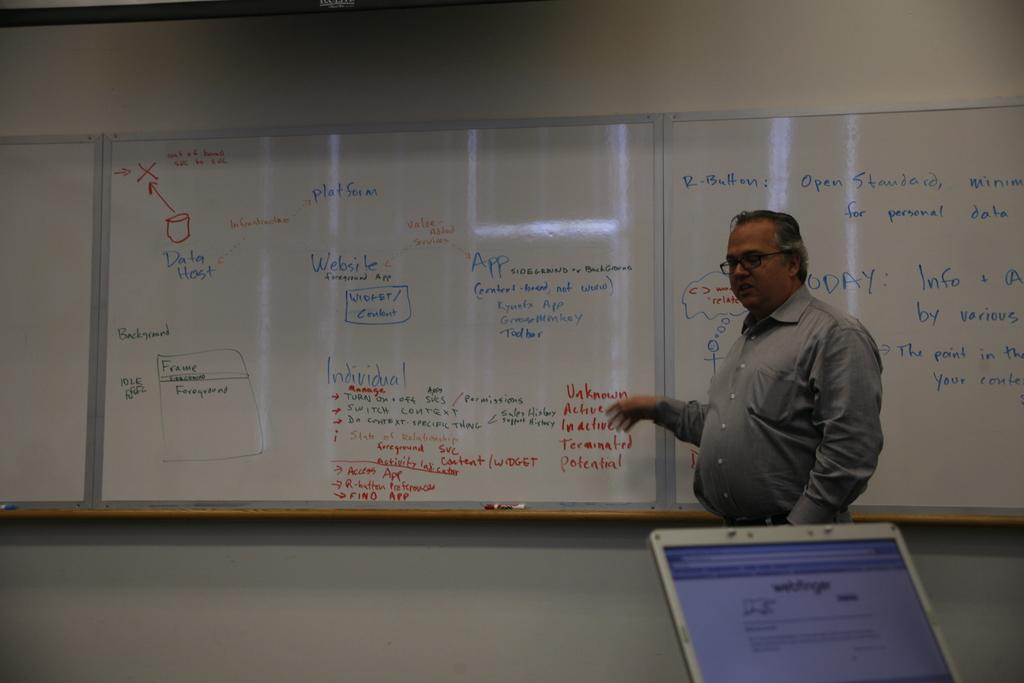<image>
Describe the image concisely. The instructor is teaching a web development class and is discussing frames and data hosts. 